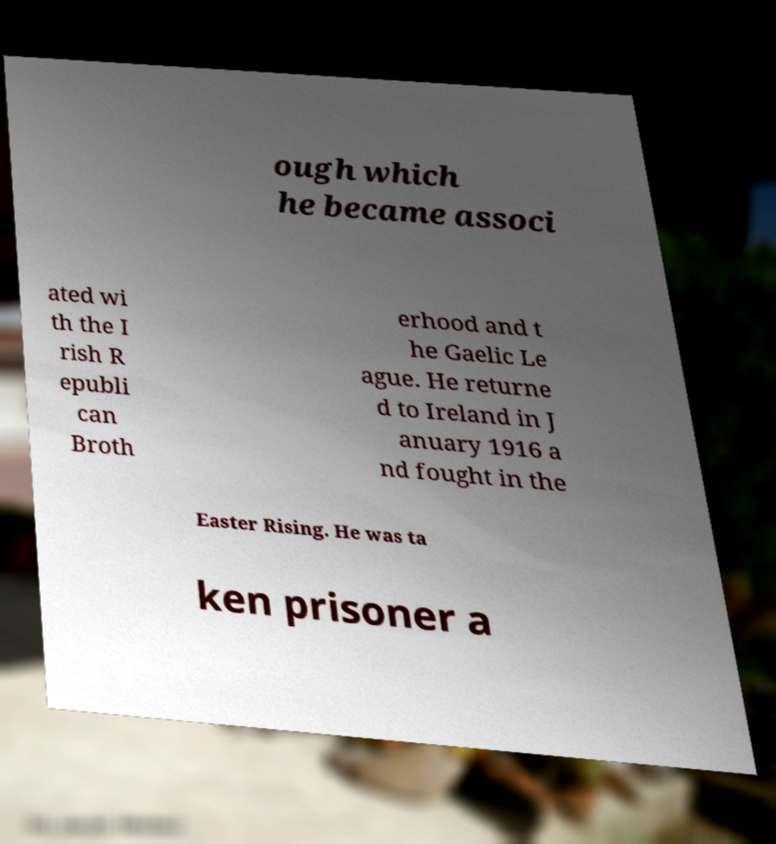Please identify and transcribe the text found in this image. ough which he became associ ated wi th the I rish R epubli can Broth erhood and t he Gaelic Le ague. He returne d to Ireland in J anuary 1916 a nd fought in the Easter Rising. He was ta ken prisoner a 